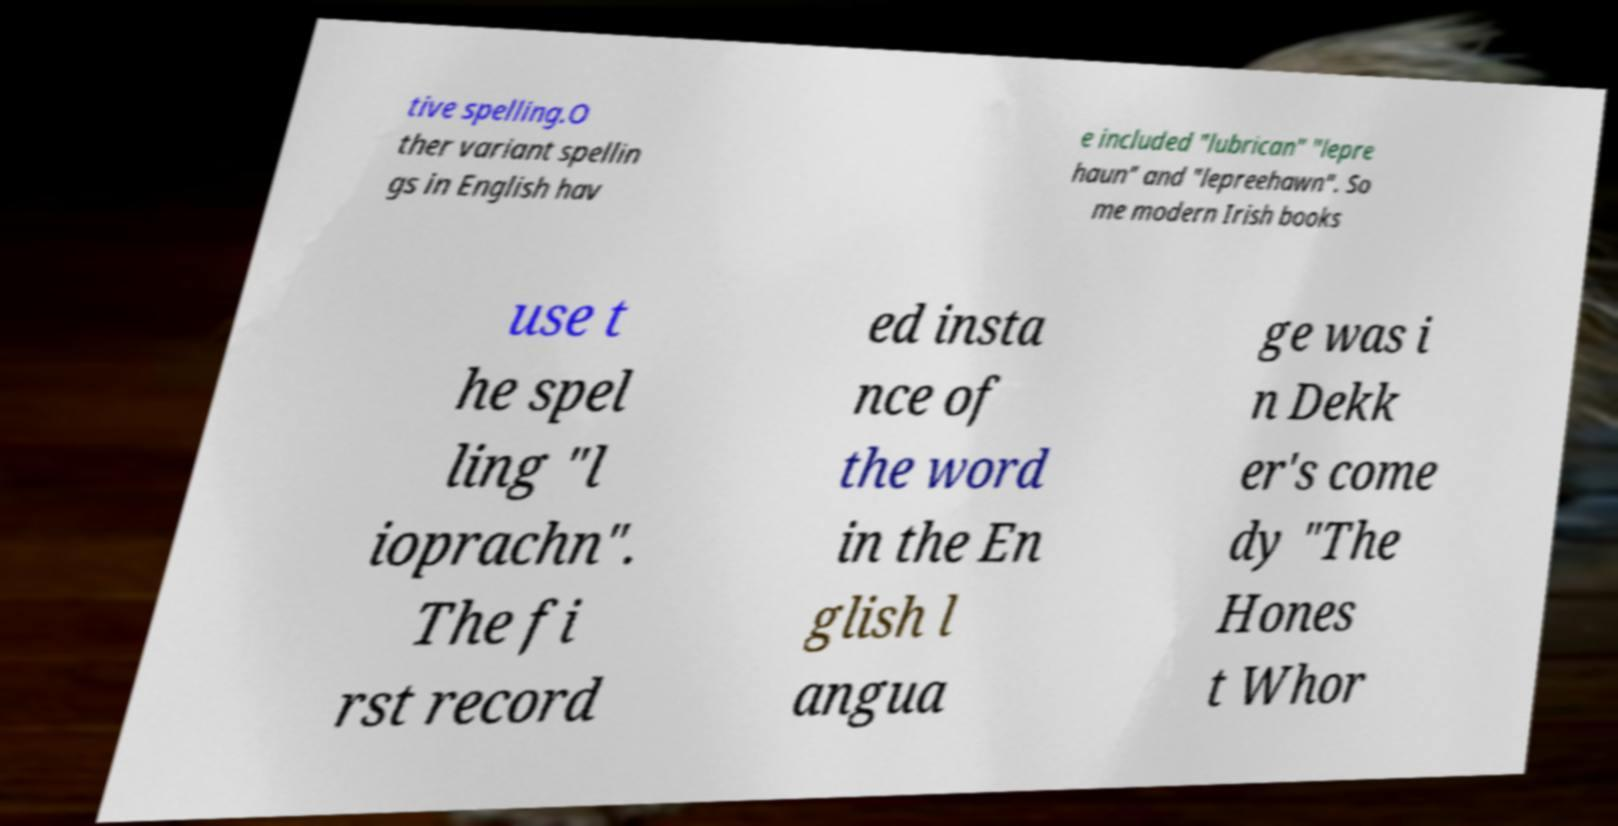Could you assist in decoding the text presented in this image and type it out clearly? tive spelling.O ther variant spellin gs in English hav e included "lubrican" "lepre haun" and "lepreehawn". So me modern Irish books use t he spel ling "l ioprachn". The fi rst record ed insta nce of the word in the En glish l angua ge was i n Dekk er's come dy "The Hones t Whor 